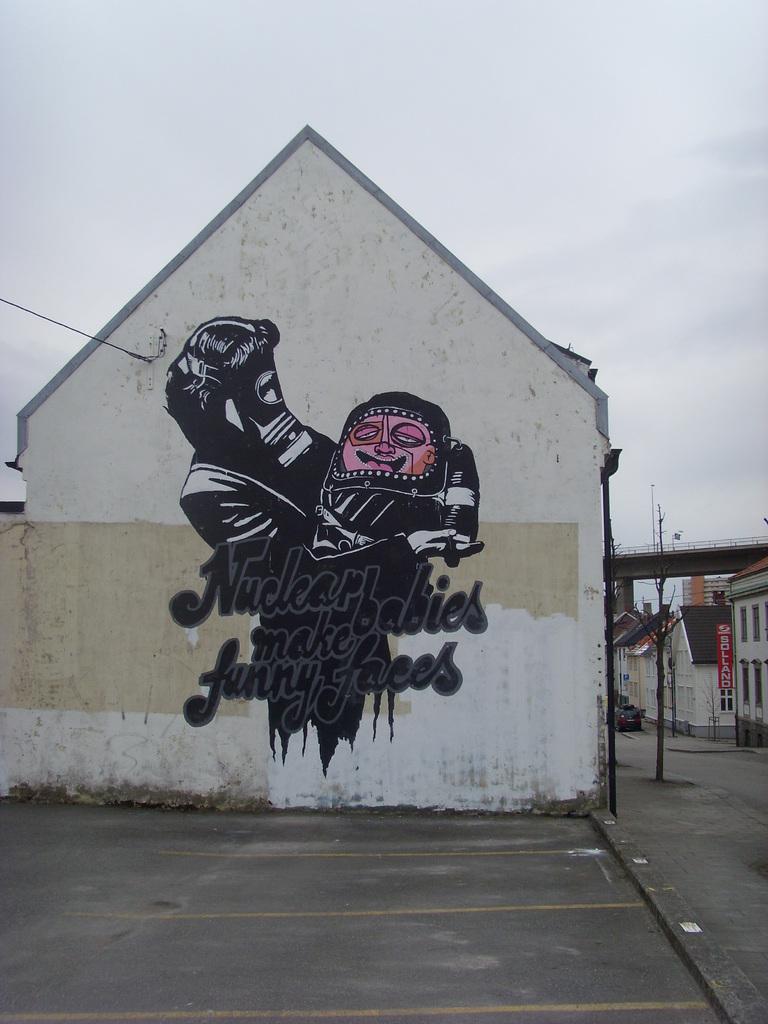What does this mural say?
Give a very brief answer. Nuclear babies make funny faces. What does the red sign say?
Your answer should be compact. Solland. 